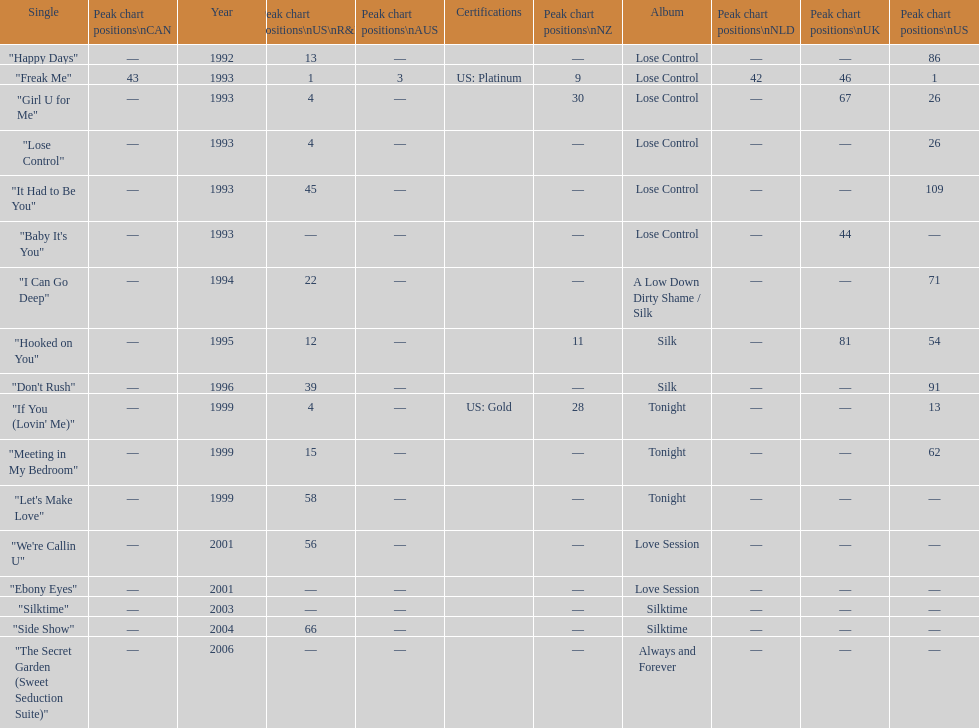Which single is the most in terms of how many times it charted? "Freak Me". 